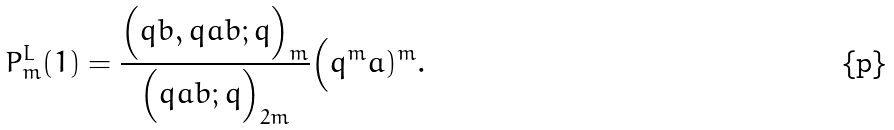<formula> <loc_0><loc_0><loc_500><loc_500>P _ { m } ^ { L } ( 1 ) = \frac { \Big ( q b , q a b ; q \Big ) _ { m } } { \Big ( q a b ; q \Big ) _ { 2 m } } \Big ( q ^ { m } a ) ^ { m } .</formula> 